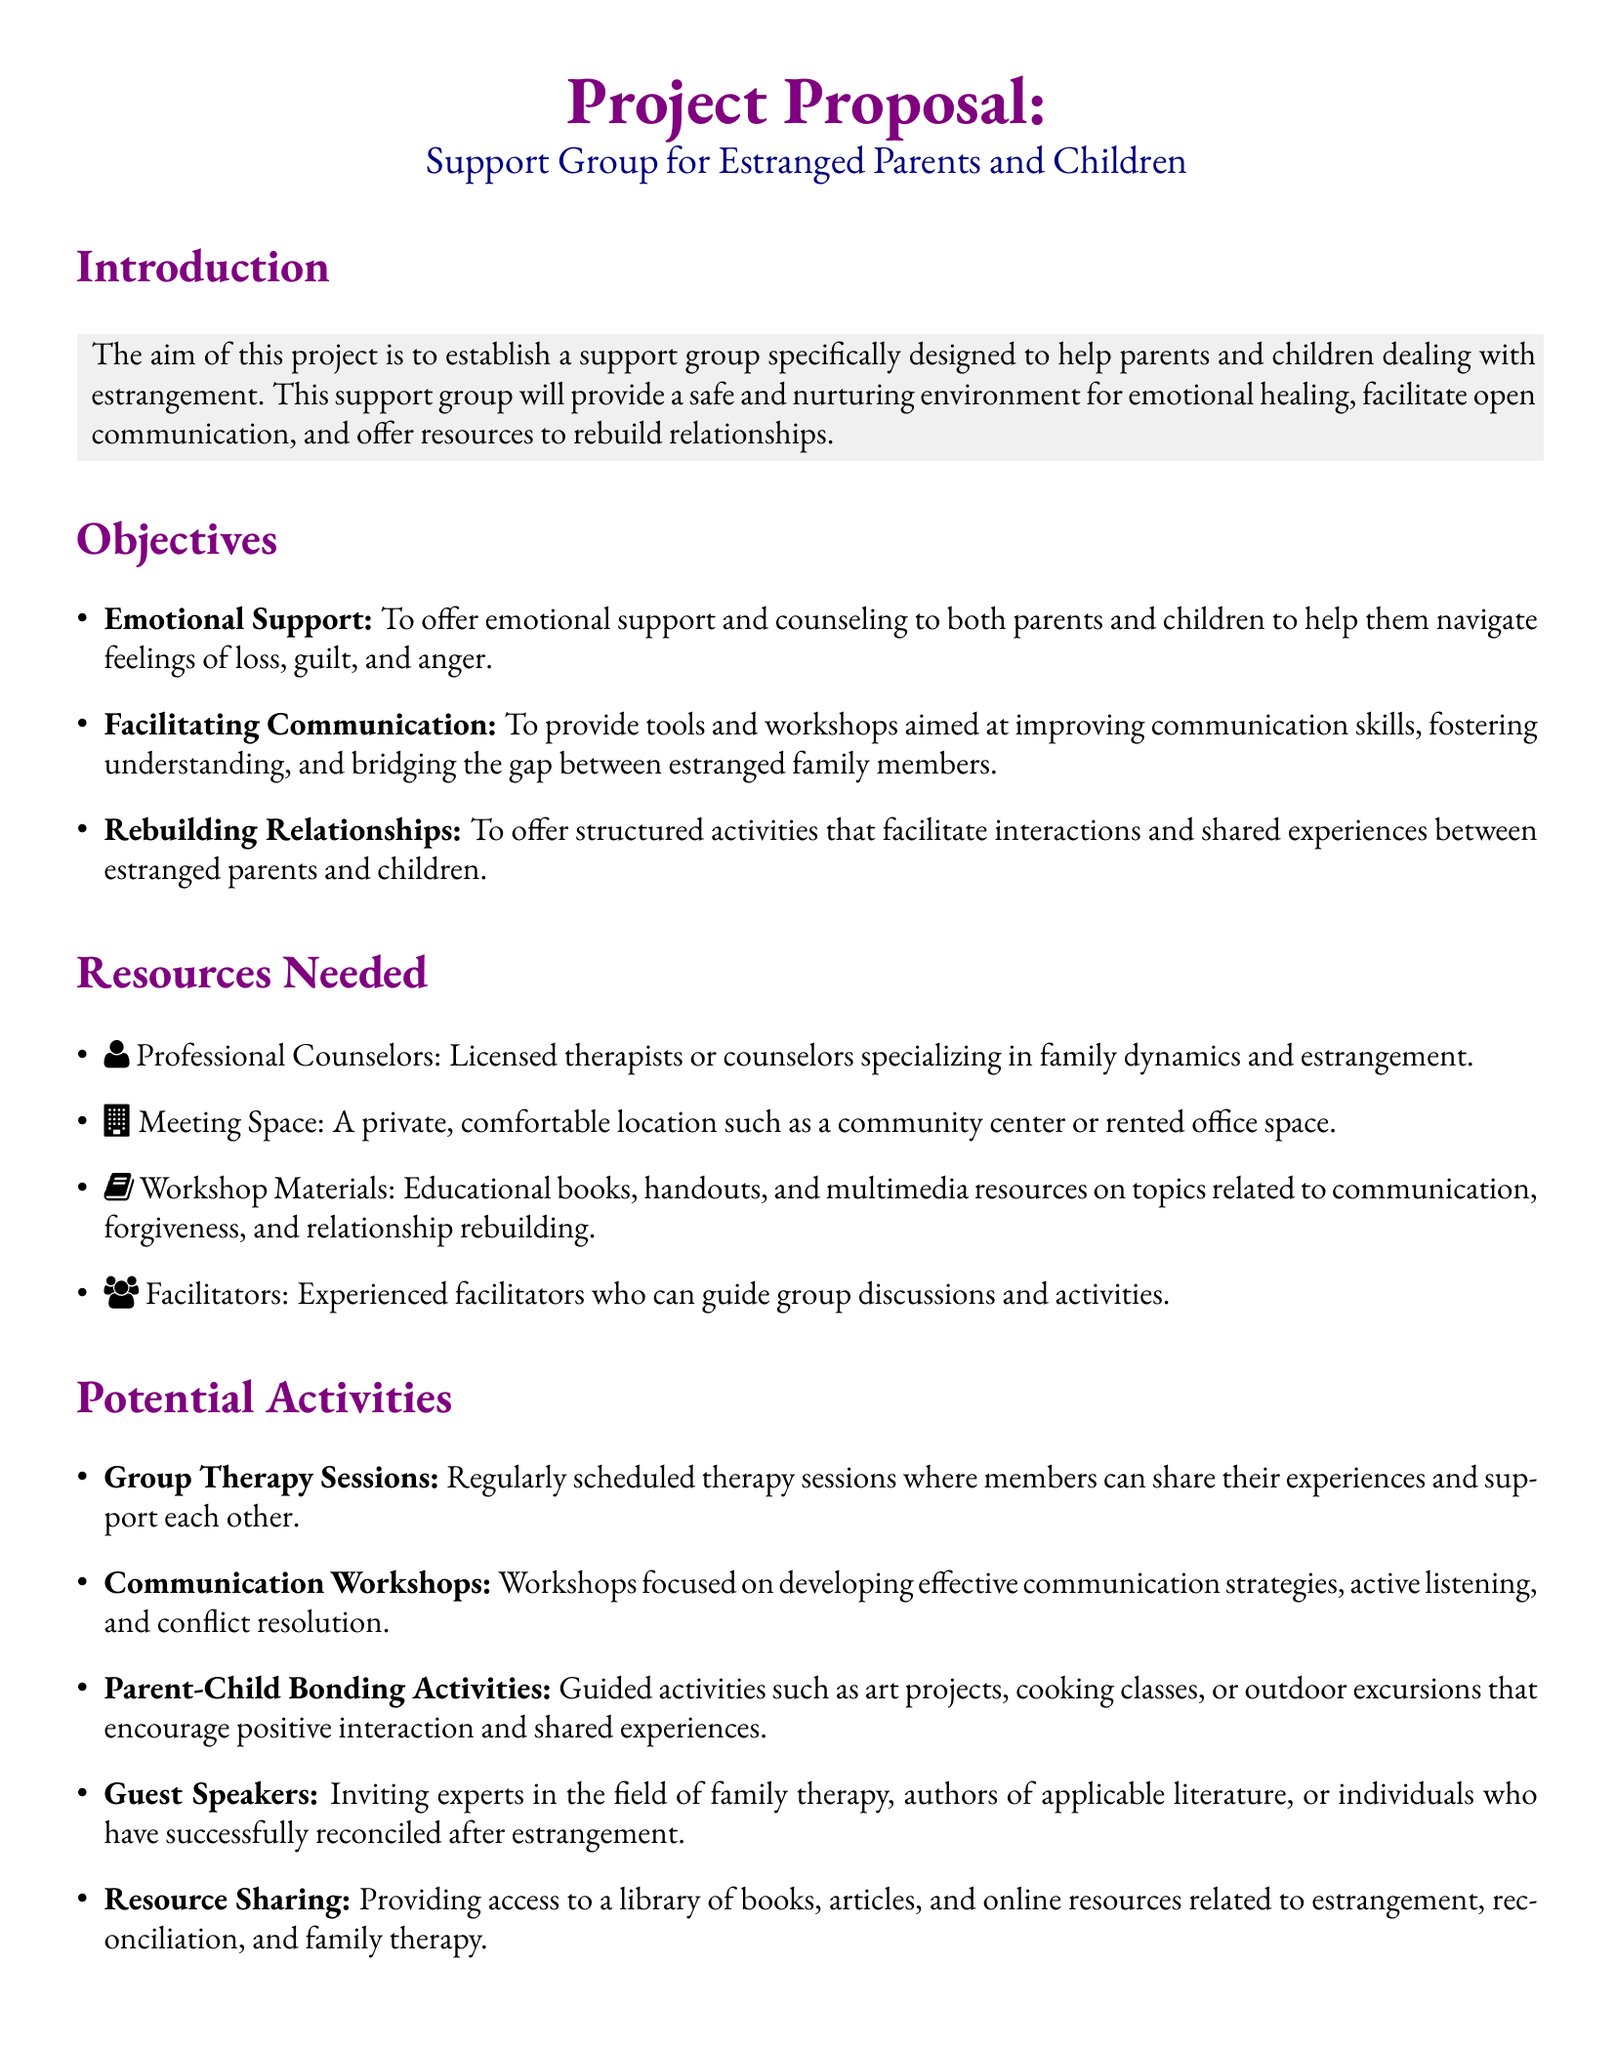What is the main purpose of the project? The project aims to establish a support group specifically designed to help parents and children dealing with estrangement.
Answer: support group for estranged parents and children How many main objectives are listed in the document? The document enumerates three specific objectives aimed at helping the participants.
Answer: three Who are the professionals needed for the support group? The document mentions professional counselors specializing in family dynamics and estrangement as a necessary resource.
Answer: counselors What type of activities does the proposal include for bonding? The document suggests guided activities such as art projects and outdoor excursions to encourage positive interaction.
Answer: art projects, cooking classes, outdoor excursions What type of workshops are proposed for improving communication? The document outlines workshops focused on developing effective communication strategies and active listening.
Answer: Communication Workshops How will emotional support be provided according to the objectives? The proposal aims to offer emotional support and counseling to both parents and children navigating difficult feelings.
Answer: emotional support and counseling What is one potential activity involving outside experts? The document lists inviting guest speakers as a potential activity to enrich the support group sessions.
Answer: Guest Speakers What resources are suggested for educational content? The document lists educational books, handouts, and multimedia resources on related topics as workshop materials.
Answer: educational books, handouts, multimedia resources What is the overall aim of the support group? The objective is to provide a safe and nurturing environment for emotional healing, communication, and rebuilding relationships.
Answer: emotional healing and rebuilding relationships 